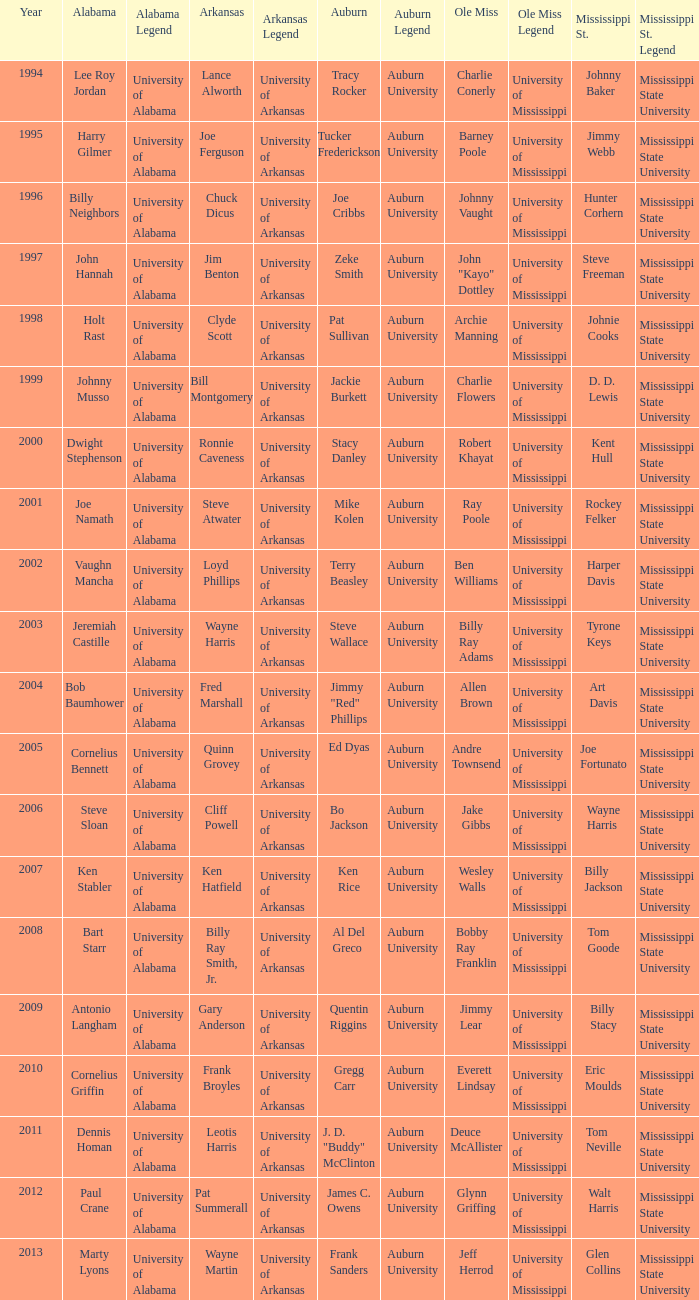Who was the player associated with Ole Miss in years after 2008 with a Mississippi St. name of Eric Moulds? Everett Lindsay. 